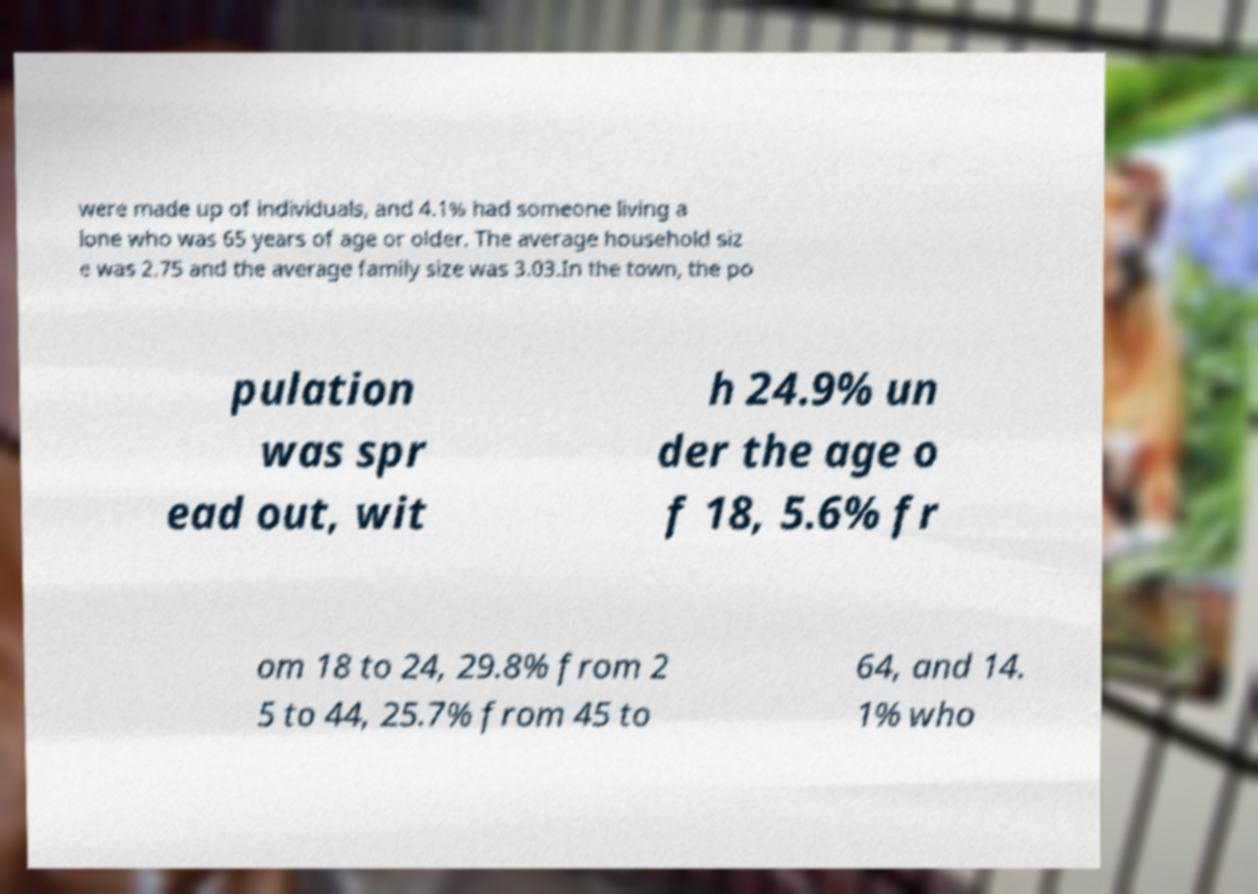Could you assist in decoding the text presented in this image and type it out clearly? were made up of individuals, and 4.1% had someone living a lone who was 65 years of age or older. The average household siz e was 2.75 and the average family size was 3.03.In the town, the po pulation was spr ead out, wit h 24.9% un der the age o f 18, 5.6% fr om 18 to 24, 29.8% from 2 5 to 44, 25.7% from 45 to 64, and 14. 1% who 